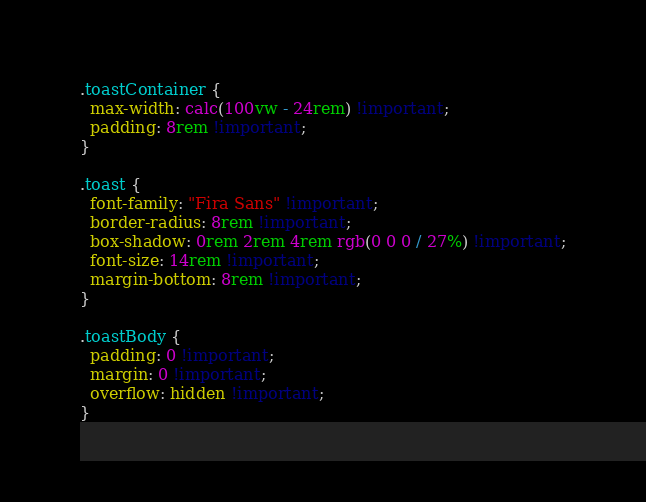Convert code to text. <code><loc_0><loc_0><loc_500><loc_500><_CSS_>.toastContainer {
  max-width: calc(100vw - 24rem) !important;
  padding: 8rem !important;
}

.toast {
  font-family: "Fira Sans" !important;
  border-radius: 8rem !important;
  box-shadow: 0rem 2rem 4rem rgb(0 0 0 / 27%) !important;
  font-size: 14rem !important;
  margin-bottom: 8rem !important;
}

.toastBody {
  padding: 0 !important;
  margin: 0 !important;
  overflow: hidden !important;
}
</code> 